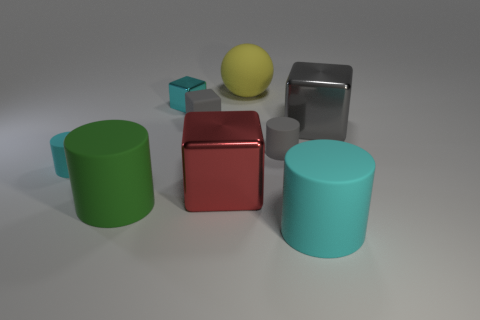Are there any cyan rubber cylinders that have the same size as the gray matte cylinder?
Offer a very short reply. Yes. The gray thing that is to the left of the yellow object behind the cyan rubber thing to the right of the big red metallic thing is what shape?
Offer a terse response. Cube. Are there more cyan matte things behind the big red metal block than big cyan rubber cubes?
Give a very brief answer. Yes. Are there any small blue shiny things that have the same shape as the large gray shiny object?
Ensure brevity in your answer.  No. Are the tiny cyan block and the small cylinder right of the small cyan cube made of the same material?
Provide a succinct answer. No. What is the color of the matte block?
Offer a terse response. Gray. What number of cyan things are to the right of the cyan rubber object to the left of the small gray thing that is right of the big yellow rubber sphere?
Your response must be concise. 2. There is a gray metal block; are there any big objects behind it?
Ensure brevity in your answer.  Yes. What number of gray cubes have the same material as the large green cylinder?
Your response must be concise. 1. What number of objects are cyan matte things or large matte balls?
Your response must be concise. 3. 